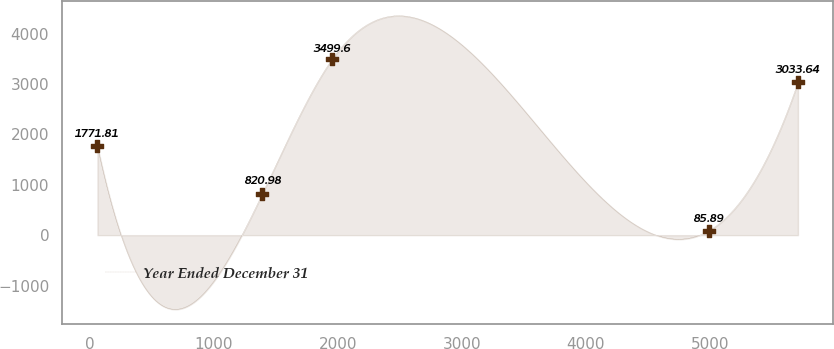<chart> <loc_0><loc_0><loc_500><loc_500><line_chart><ecel><fcel>Year Ended December 31<nl><fcel>63.1<fcel>1771.81<nl><fcel>1392.74<fcel>820.98<nl><fcel>1957.46<fcel>3499.6<nl><fcel>4991.25<fcel>85.89<nl><fcel>5710.32<fcel>3033.64<nl></chart> 